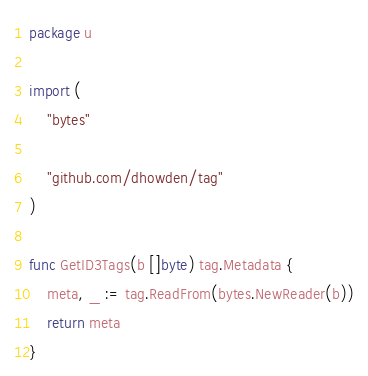Convert code to text. <code><loc_0><loc_0><loc_500><loc_500><_Go_>package u

import (
	"bytes"

	"github.com/dhowden/tag"
)

func GetID3Tags(b []byte) tag.Metadata {
	meta, _ := tag.ReadFrom(bytes.NewReader(b))
	return meta
}
</code> 